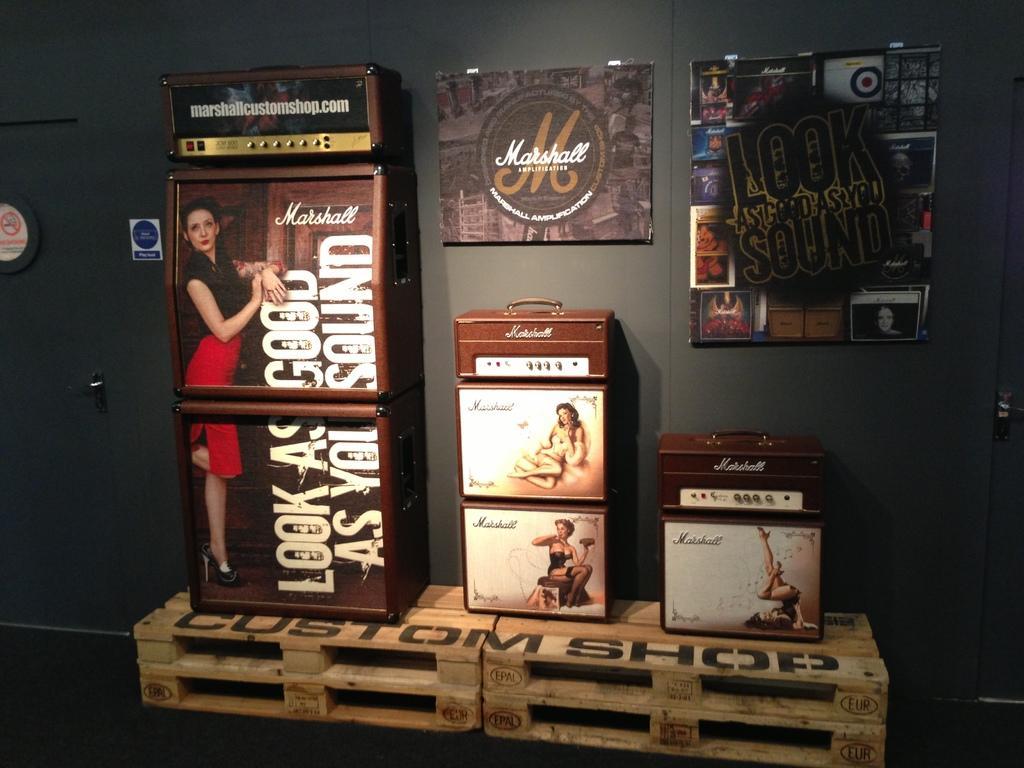In one or two sentences, can you explain what this image depicts? In the picture we can see boxes on which we can see the images and some text are placed on the wooden boxes and we can two frames fixed to the wall. O n the left side of the image we can see a door. 